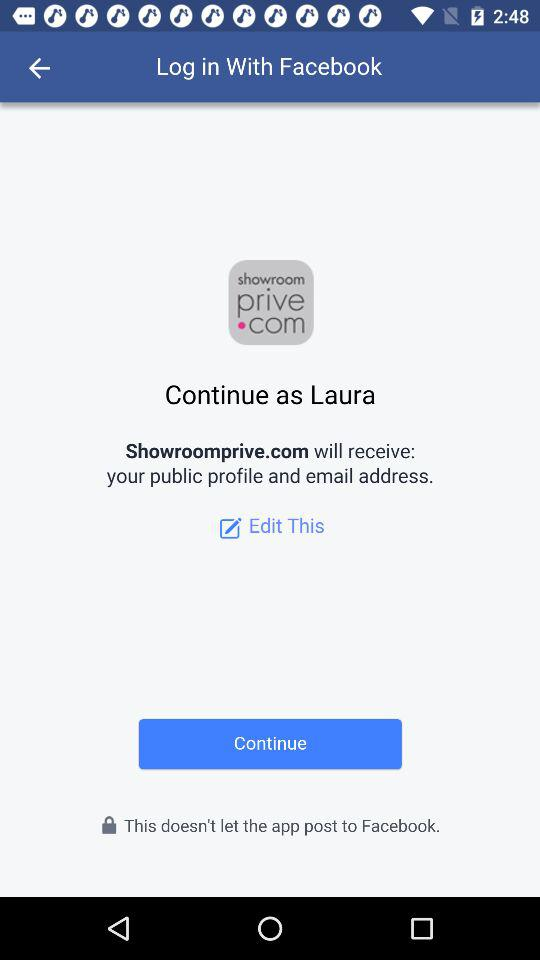What application will receive the public profile and email address? The application that will receive the public profile and email address is "Showroomprive.com". 